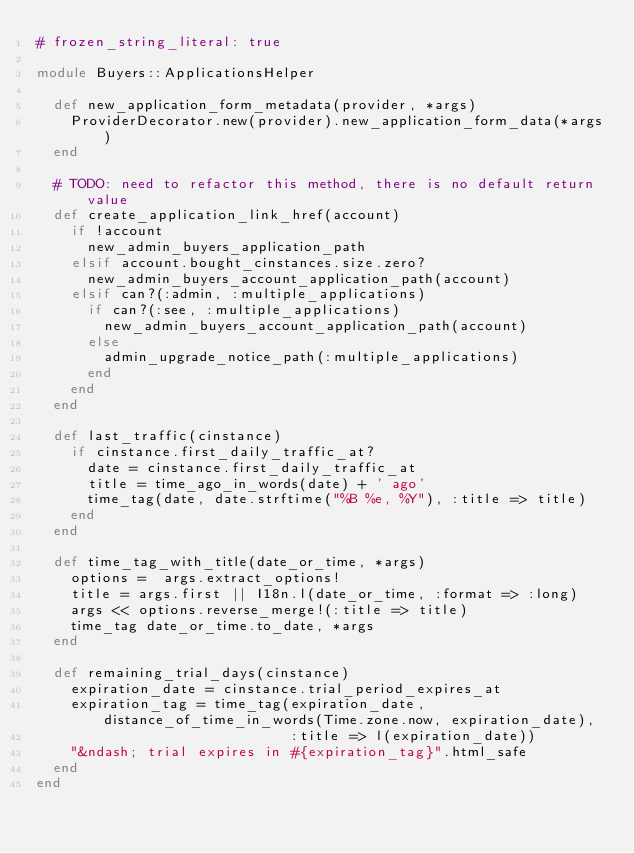Convert code to text. <code><loc_0><loc_0><loc_500><loc_500><_Ruby_># frozen_string_literal: true

module Buyers::ApplicationsHelper

  def new_application_form_metadata(provider, *args)
    ProviderDecorator.new(provider).new_application_form_data(*args)
  end

  # TODO: need to refactor this method, there is no default return value
  def create_application_link_href(account)
    if !account
      new_admin_buyers_application_path
    elsif account.bought_cinstances.size.zero?
      new_admin_buyers_account_application_path(account)
    elsif can?(:admin, :multiple_applications)
      if can?(:see, :multiple_applications)
        new_admin_buyers_account_application_path(account)
      else
        admin_upgrade_notice_path(:multiple_applications)
      end
    end
  end

  def last_traffic(cinstance)
    if cinstance.first_daily_traffic_at?
      date = cinstance.first_daily_traffic_at
      title = time_ago_in_words(date) + ' ago'
      time_tag(date, date.strftime("%B %e, %Y"), :title => title)
    end
  end

  def time_tag_with_title(date_or_time, *args)
    options =  args.extract_options!
    title = args.first || I18n.l(date_or_time, :format => :long)
    args << options.reverse_merge!(:title => title)
    time_tag date_or_time.to_date, *args
  end

  def remaining_trial_days(cinstance)
    expiration_date = cinstance.trial_period_expires_at
    expiration_tag = time_tag(expiration_date, distance_of_time_in_words(Time.zone.now, expiration_date),
                              :title => l(expiration_date))
    "&ndash; trial expires in #{expiration_tag}".html_safe
  end
end
</code> 